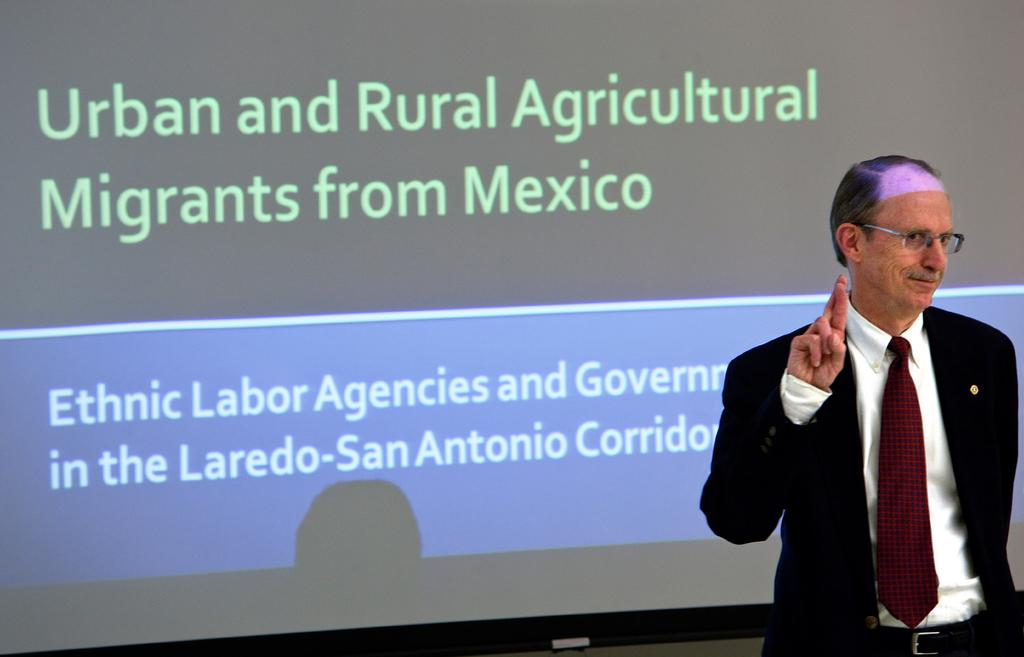Who is present in the image? There is a person in the image. Where is the person located in the image? The person is on the right side of the image. What is the person doing in the image? The person is explaining something. What can be seen behind the person in the image? There is text visible behind the person. What type of advice do the fairies give in the image? There are no fairies present in the image, so it is not possible to answer that question. 